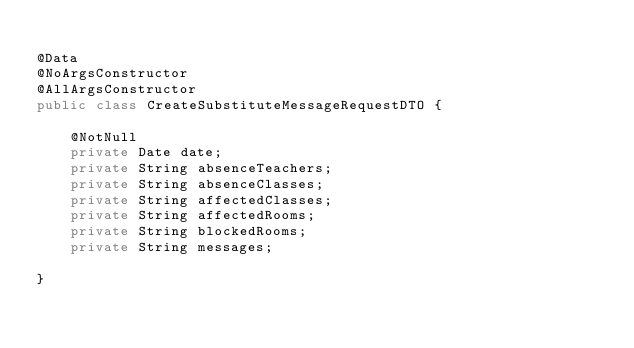Convert code to text. <code><loc_0><loc_0><loc_500><loc_500><_Java_>
@Data
@NoArgsConstructor
@AllArgsConstructor
public class CreateSubstituteMessageRequestDTO {

	@NotNull
	private Date date;
	private String absenceTeachers;
	private String absenceClasses;
	private String affectedClasses;
	private String affectedRooms;
	private String blockedRooms;
	private String messages;

}
</code> 